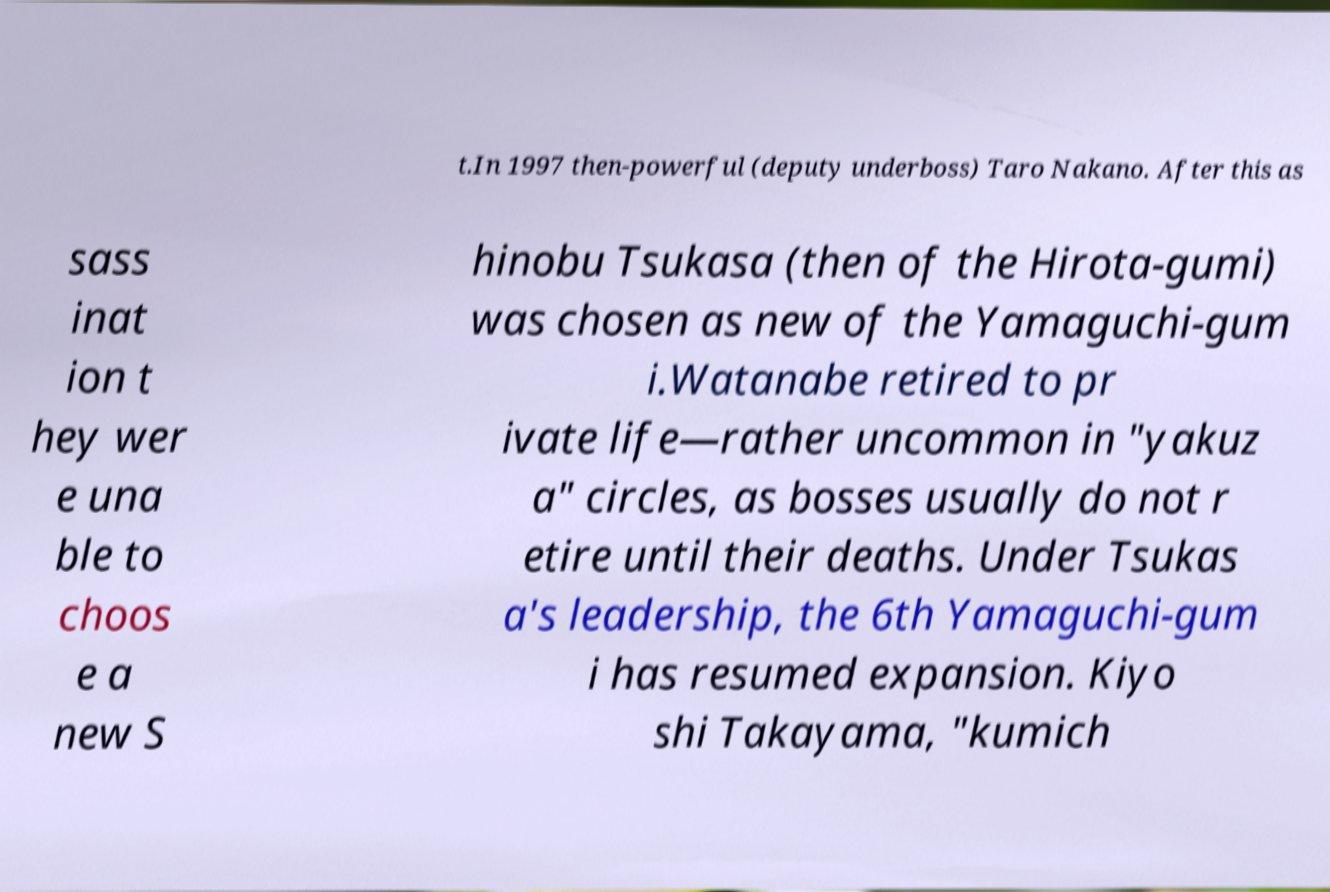Please read and relay the text visible in this image. What does it say? t.In 1997 then-powerful (deputy underboss) Taro Nakano. After this as sass inat ion t hey wer e una ble to choos e a new S hinobu Tsukasa (then of the Hirota-gumi) was chosen as new of the Yamaguchi-gum i.Watanabe retired to pr ivate life—rather uncommon in "yakuz a" circles, as bosses usually do not r etire until their deaths. Under Tsukas a's leadership, the 6th Yamaguchi-gum i has resumed expansion. Kiyo shi Takayama, "kumich 